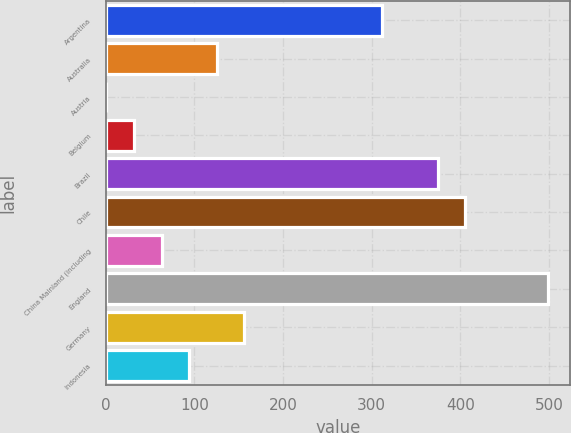<chart> <loc_0><loc_0><loc_500><loc_500><bar_chart><fcel>Argentina<fcel>Australia<fcel>Austria<fcel>Belgium<fcel>Brazil<fcel>Chile<fcel>China Mainland (including<fcel>England<fcel>Germany<fcel>Indonesia<nl><fcel>312<fcel>125.4<fcel>1<fcel>32.1<fcel>374.2<fcel>405.3<fcel>63.2<fcel>498.6<fcel>156.5<fcel>94.3<nl></chart> 